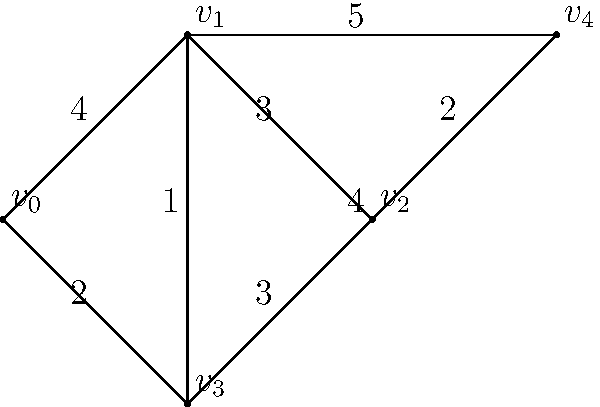Consider the weighted graph shown above. Using Kruskal's algorithm, determine the minimum spanning tree of this network. What is the total weight of the minimum spanning tree? To find the minimum spanning tree using Kruskal's algorithm, we follow these steps:

1. Sort all edges by weight in ascending order:
   $(v_1, v_3, 1)$, $(v_0, v_3, 2)$, $(v_2, v_4, 2)$, $(v_1, v_2, 3)$, $(v_2, v_3, 3)$, $(v_0, v_1, 4)$, $(v_3, v_4, 4)$, $(v_1, v_4, 5)$

2. Start with an empty set of edges and add edges that don't create cycles:
   - Add $(v_1, v_3, 1)$
   - Add $(v_0, v_3, 2)$
   - Add $(v_2, v_4, 2)$
   - Skip $(v_1, v_2, 3)$ as it would create a cycle
   - Skip $(v_2, v_3, 3)$ as it would create a cycle
   - Add $(v_0, v_1, 4)$ to connect the last vertex

3. The minimum spanning tree now includes these edges:
   $(v_1, v_3)$, $(v_0, v_3)$, $(v_2, v_4)$, $(v_0, v_1)$

4. Calculate the total weight:
   $1 + 2 + 2 + 4 = 9$

Therefore, the total weight of the minimum spanning tree is 9.
Answer: 9 